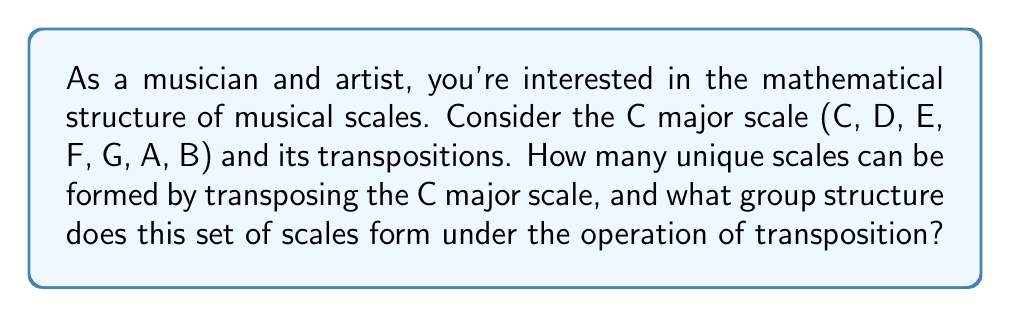Provide a solution to this math problem. Let's approach this step-by-step:

1) First, recall that there are 12 semitones in an octave. The C major scale can be represented as a sequence of whole and half steps: W-W-H-W-W-W-H.

2) Transposing the scale means shifting all notes by the same number of semitones. For example, transposing up by 1 semitone gives C# major scale.

3) We can represent each transposition by the number of semitones it's shifted from C. So C major is 0, C# major is 1, D major is 2, and so on.

4) The question is: how many unique scales do we get by transposing?

   We get 12 unique scales: 0 (C), 1 (C#), 2 (D), ..., 11 (B)

5) Now, let's consider the group structure:
   - The set of elements is {0, 1, 2, ..., 11}
   - The operation is addition modulo 12 (because after 11 semitones, we're back to the original scale)

6) This forms a cyclic group of order 12, often denoted as $\mathbb{Z}_{12}$ or $C_{12}$

7) Properties of this group:
   - Closure: $(a + b) \mod 12$ is always in the set
   - Associativity: $((a + b) + c) \mod 12 = (a + (b + c)) \mod 12$
   - Identity: 0 (no transposition)
   - Inverse: For each element $a$, there exists $12-a$ such that $(a + (12-a)) \mod 12 = 0$

8) This group is isomorphic to the group of rotational symmetries of a regular dodecagon.

For the artist persona, this structure relates to the cyclical nature of scales and keys in music, which can be visualized as a circle (similar to the color wheel used in visual arts).
Answer: There are 12 unique scales formed by transposing the C major scale. These scales form a cyclic group of order 12, denoted as $\mathbb{Z}_{12}$ or $C_{12}$, under the operation of transposition (addition modulo 12). 